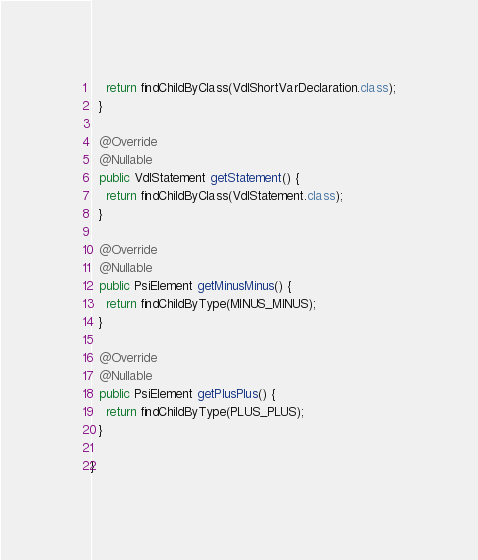<code> <loc_0><loc_0><loc_500><loc_500><_Java_>    return findChildByClass(VdlShortVarDeclaration.class);
  }

  @Override
  @Nullable
  public VdlStatement getStatement() {
    return findChildByClass(VdlStatement.class);
  }

  @Override
  @Nullable
  public PsiElement getMinusMinus() {
    return findChildByType(MINUS_MINUS);
  }

  @Override
  @Nullable
  public PsiElement getPlusPlus() {
    return findChildByType(PLUS_PLUS);
  }

}
</code> 